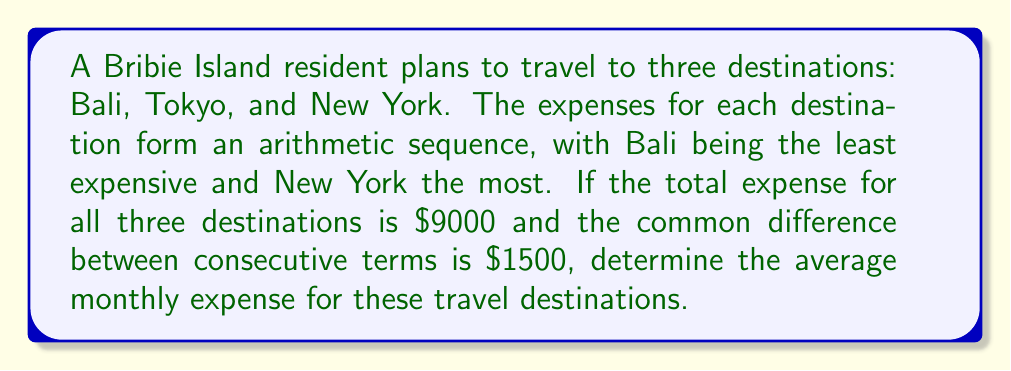Teach me how to tackle this problem. Let's approach this step-by-step:

1) Let $a$ be the expense for Bali (the first term in the sequence).
   Then, the expenses for the three destinations form the sequence:
   $a, a+1500, a+3000$

2) We know the sum of these expenses is $9000. We can express this as an equation:
   $a + (a+1500) + (a+3000) = 9000$

3) Simplify the left side of the equation:
   $3a + 4500 = 9000$

4) Solve for $a$:
   $3a = 9000 - 4500 = 4500$
   $a = 1500$

5) Now we know the expenses for each destination:
   Bali: $1500
   Tokyo: $3000
   New York: $4500

6) To find the average monthly expense, we sum these values and divide by 3:
   
   $$\text{Average} = \frac{1500 + 3000 + 4500}{3} = \frac{9000}{3} = 3000$$

Therefore, the average monthly expense for these travel destinations is $3000.
Answer: $3000 